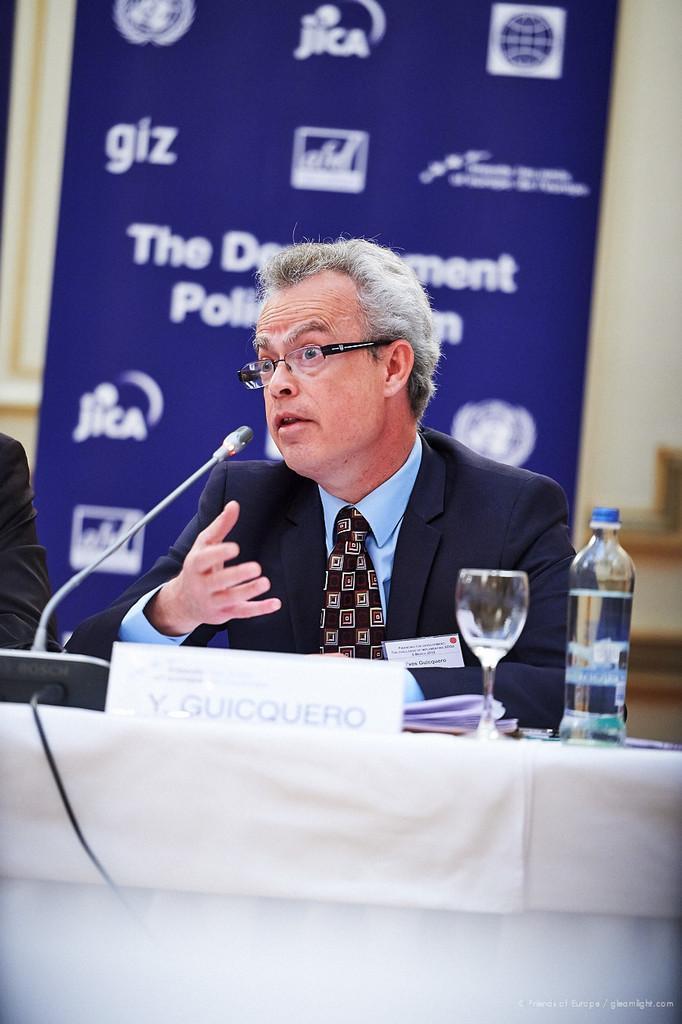Could you give a brief overview of what you see in this image? In the center we can see on man he is sitting on the chair. In front of him there is a table on table we can see one glass and one water bottle and some other objects. And back of him we can see banner. 